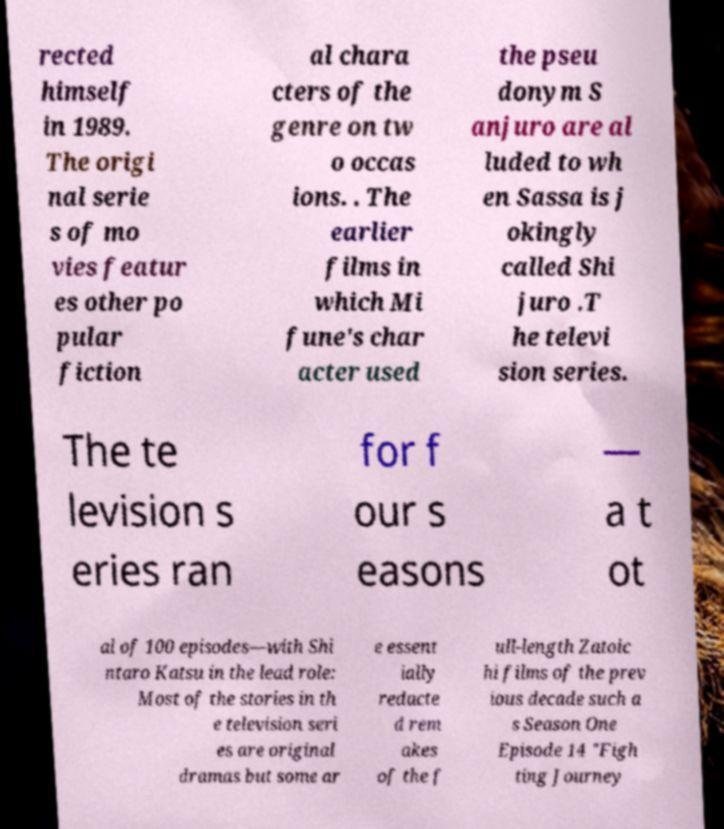Can you read and provide the text displayed in the image?This photo seems to have some interesting text. Can you extract and type it out for me? rected himself in 1989. The origi nal serie s of mo vies featur es other po pular fiction al chara cters of the genre on tw o occas ions. . The earlier films in which Mi fune's char acter used the pseu donym S anjuro are al luded to wh en Sassa is j okingly called Shi juro .T he televi sion series. The te levision s eries ran for f our s easons — a t ot al of 100 episodes—with Shi ntaro Katsu in the lead role: Most of the stories in th e television seri es are original dramas but some ar e essent ially redacte d rem akes of the f ull-length Zatoic hi films of the prev ious decade such a s Season One Episode 14 "Figh ting Journey 